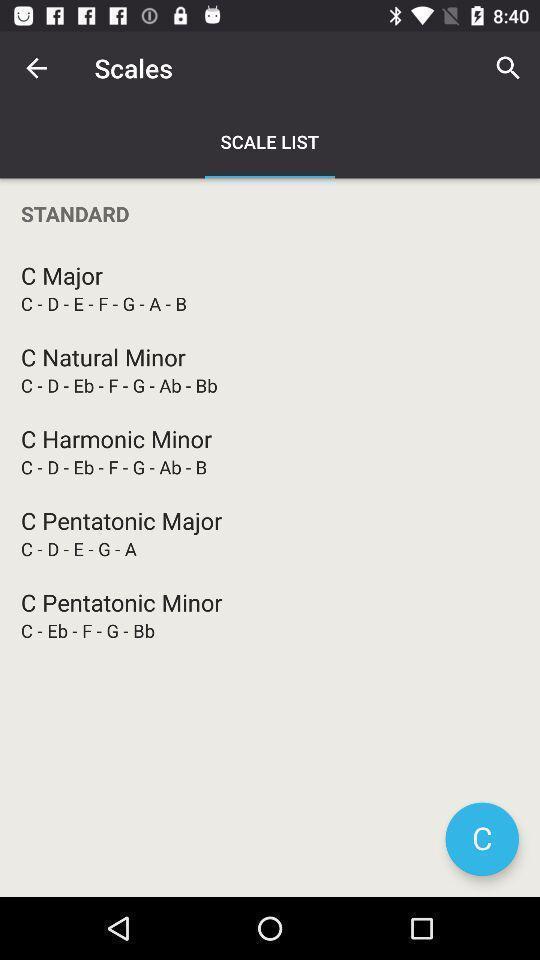Describe the visual elements of this screenshot. Search page for the music instrument learning app. 